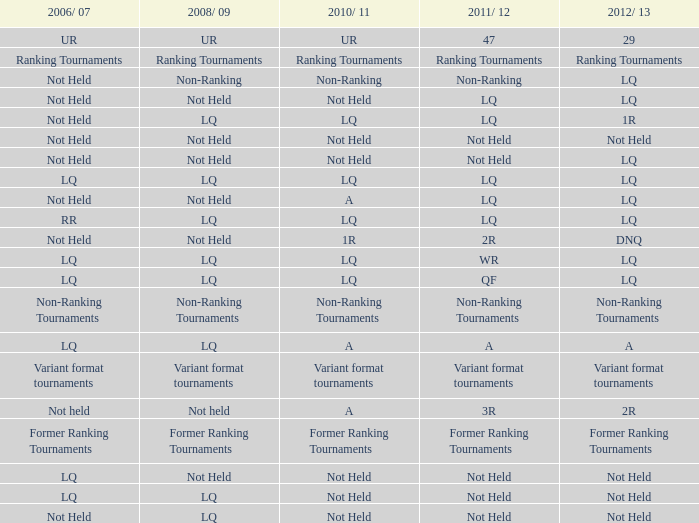With 2006/07 being ur, what would be the equivalent for 2010-11? UR. 